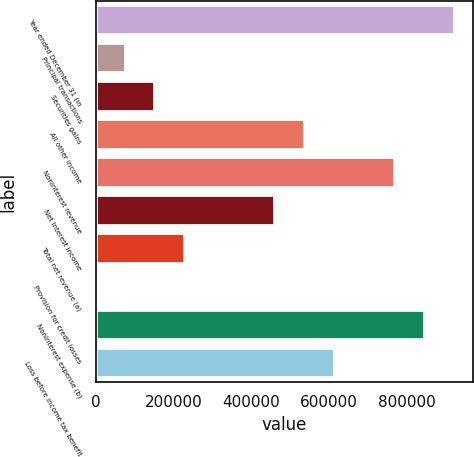<chart> <loc_0><loc_0><loc_500><loc_500><bar_chart><fcel>Year ended December 31 (in<fcel>Principal transactions<fcel>Securities gains<fcel>All other income<fcel>Noninterest revenue<fcel>Net interest income<fcel>Total net revenue (a)<fcel>Provision for credit losses<fcel>Noninterest expense (b)<fcel>Loss before income tax benefit<nl><fcel>921843<fcel>76829.4<fcel>153649<fcel>537746<fcel>768204<fcel>460926<fcel>230468<fcel>10<fcel>845023<fcel>614565<nl></chart> 